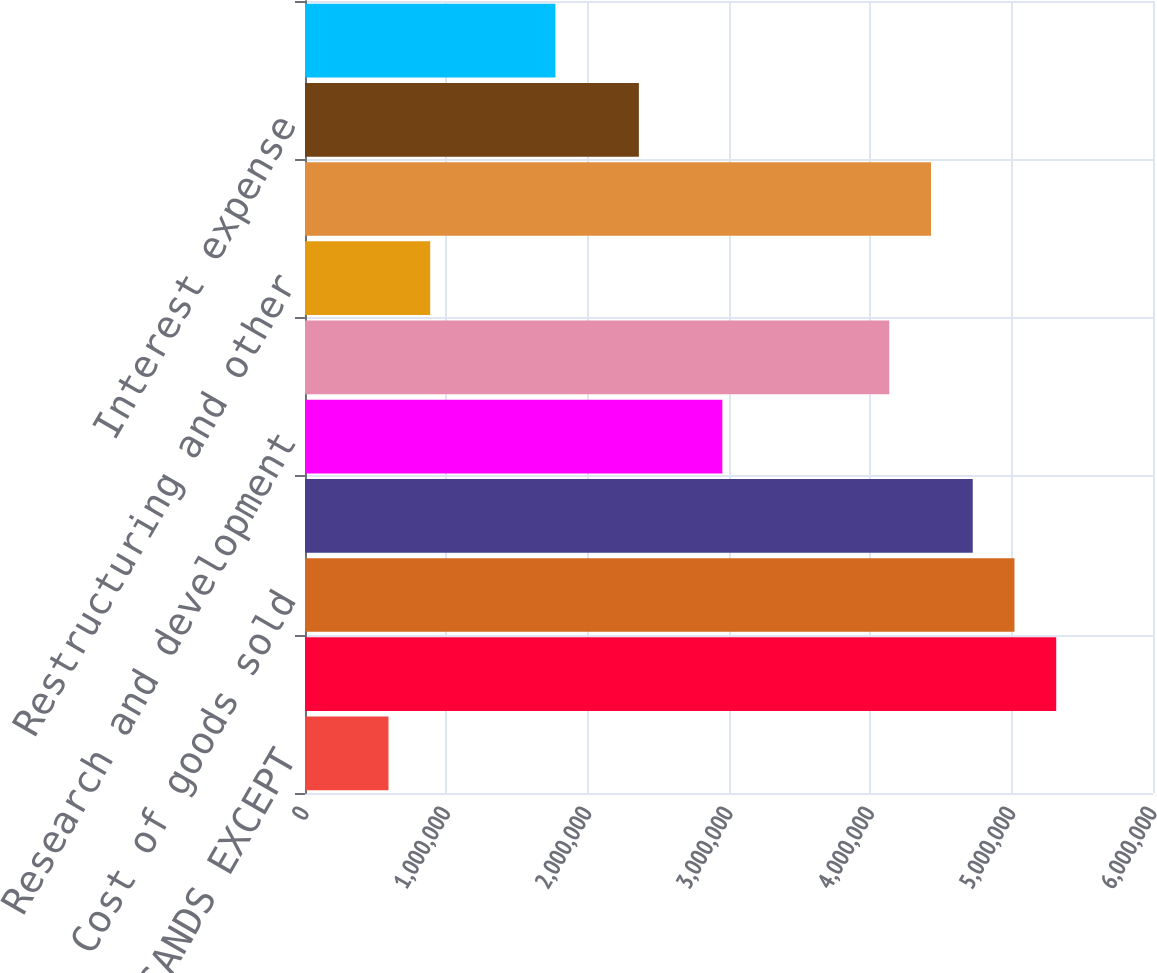Convert chart to OTSL. <chart><loc_0><loc_0><loc_500><loc_500><bar_chart><fcel>(DOLLARS IN THOUSANDS EXCEPT<fcel>Net sales<fcel>Cost of goods sold<fcel>Gross profit<fcel>Research and development<fcel>Selling and administrative<fcel>Restructuring and other<fcel>Operating profit<fcel>Interest expense<fcel>Other expense (income) net<nl><fcel>590583<fcel>5.31521e+06<fcel>5.01992e+06<fcel>4.72463e+06<fcel>2.9529e+06<fcel>4.13405e+06<fcel>885872<fcel>4.42934e+06<fcel>2.36232e+06<fcel>1.77174e+06<nl></chart> 